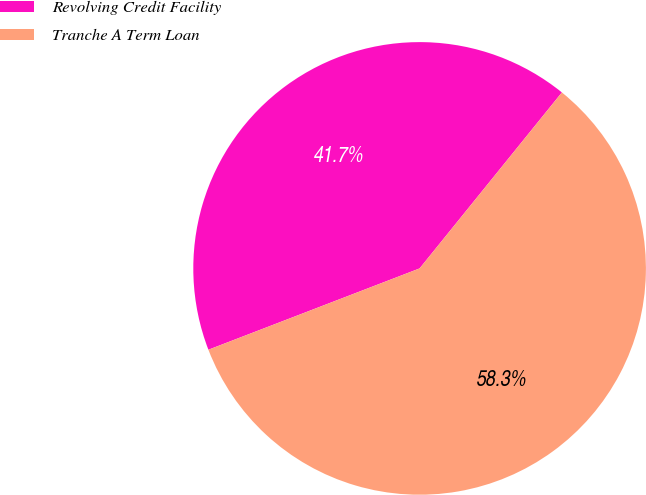<chart> <loc_0><loc_0><loc_500><loc_500><pie_chart><fcel>Revolving Credit Facility<fcel>Tranche A Term Loan<nl><fcel>41.67%<fcel>58.33%<nl></chart> 